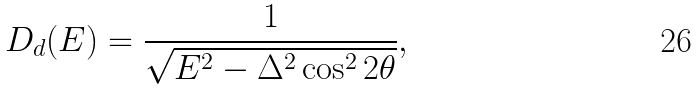Convert formula to latex. <formula><loc_0><loc_0><loc_500><loc_500>D _ { d } ( E ) = \frac { 1 } { \sqrt { E ^ { 2 } - \Delta ^ { 2 } \cos ^ { 2 } 2 \theta } } ,</formula> 